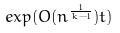Convert formula to latex. <formula><loc_0><loc_0><loc_500><loc_500>e x p ( O ( n ^ { \frac { 1 } { k - 1 } } ) t )</formula> 